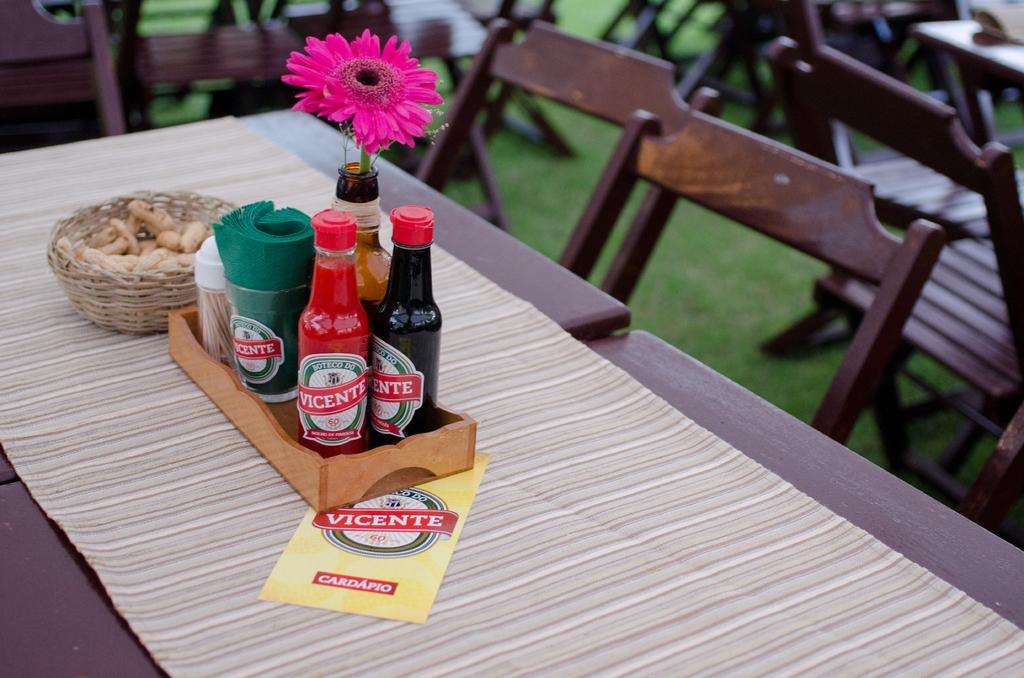What objects are on the tray in the image? There are sauce bottles on a tray, and there is a flower on top of the tray. Where is the tray located? The tray is on a dining table. What else can be seen on the table? There is food in a basket on the table. What is visible on the ground in the image? Grass is visible on the ground. What type of acoustics can be heard in the image? There is no information about acoustics in the image, as it focuses on visual elements such as the tray, sauce bottles, flower, table, food, and grass. How many frogs are sitting on the grass in the image? There are no frogs present in the image; it only features a tray, sauce bottles, flower, table, food, and grass. 